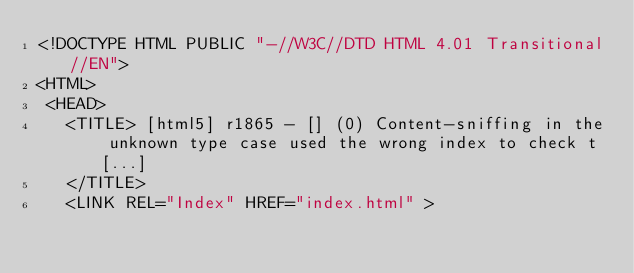<code> <loc_0><loc_0><loc_500><loc_500><_HTML_><!DOCTYPE HTML PUBLIC "-//W3C//DTD HTML 4.01 Transitional//EN">
<HTML>
 <HEAD>
   <TITLE> [html5] r1865 - [] (0) Content-sniffing in the unknown type case	used the wrong index to check t [...]
   </TITLE>
   <LINK REL="Index" HREF="index.html" ></code> 